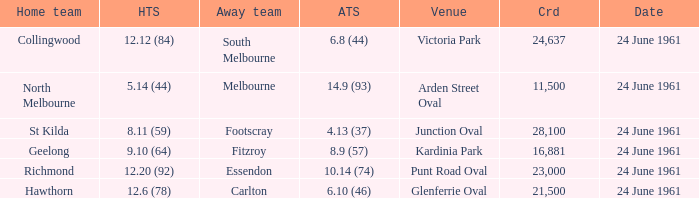What was the home team's score at the game attended by more than 24,637? 8.11 (59). 